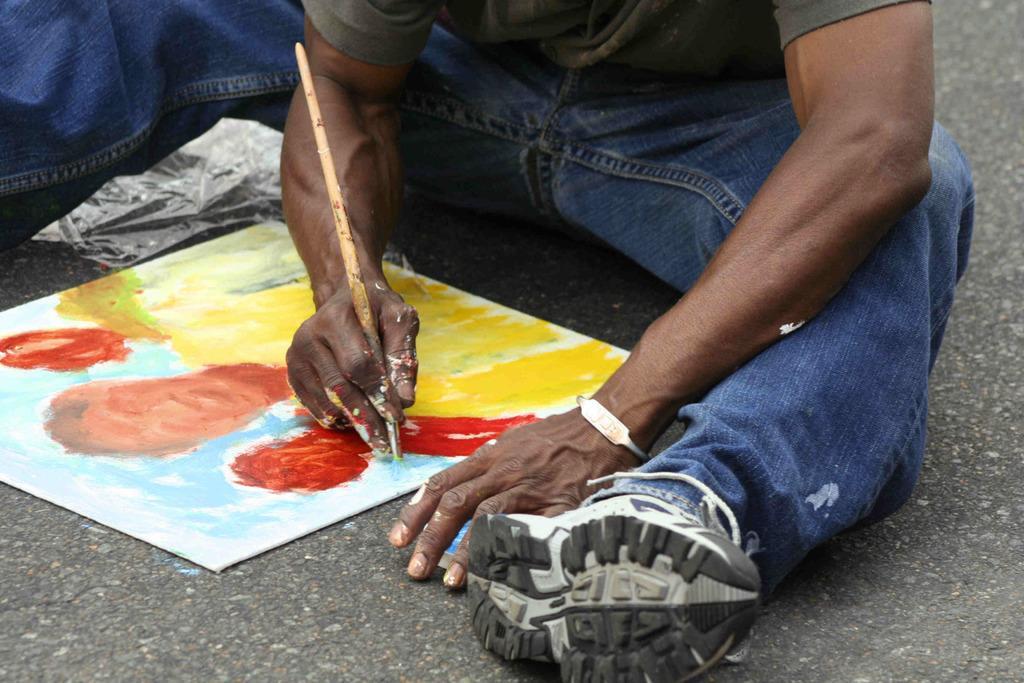How would you summarize this image in a sentence or two? The man in this picture wearing T-shirt and blue jeans is holding a painting brush in his hand and he is painting on the board or the chart. At the bottom of the picture, we see the road. 